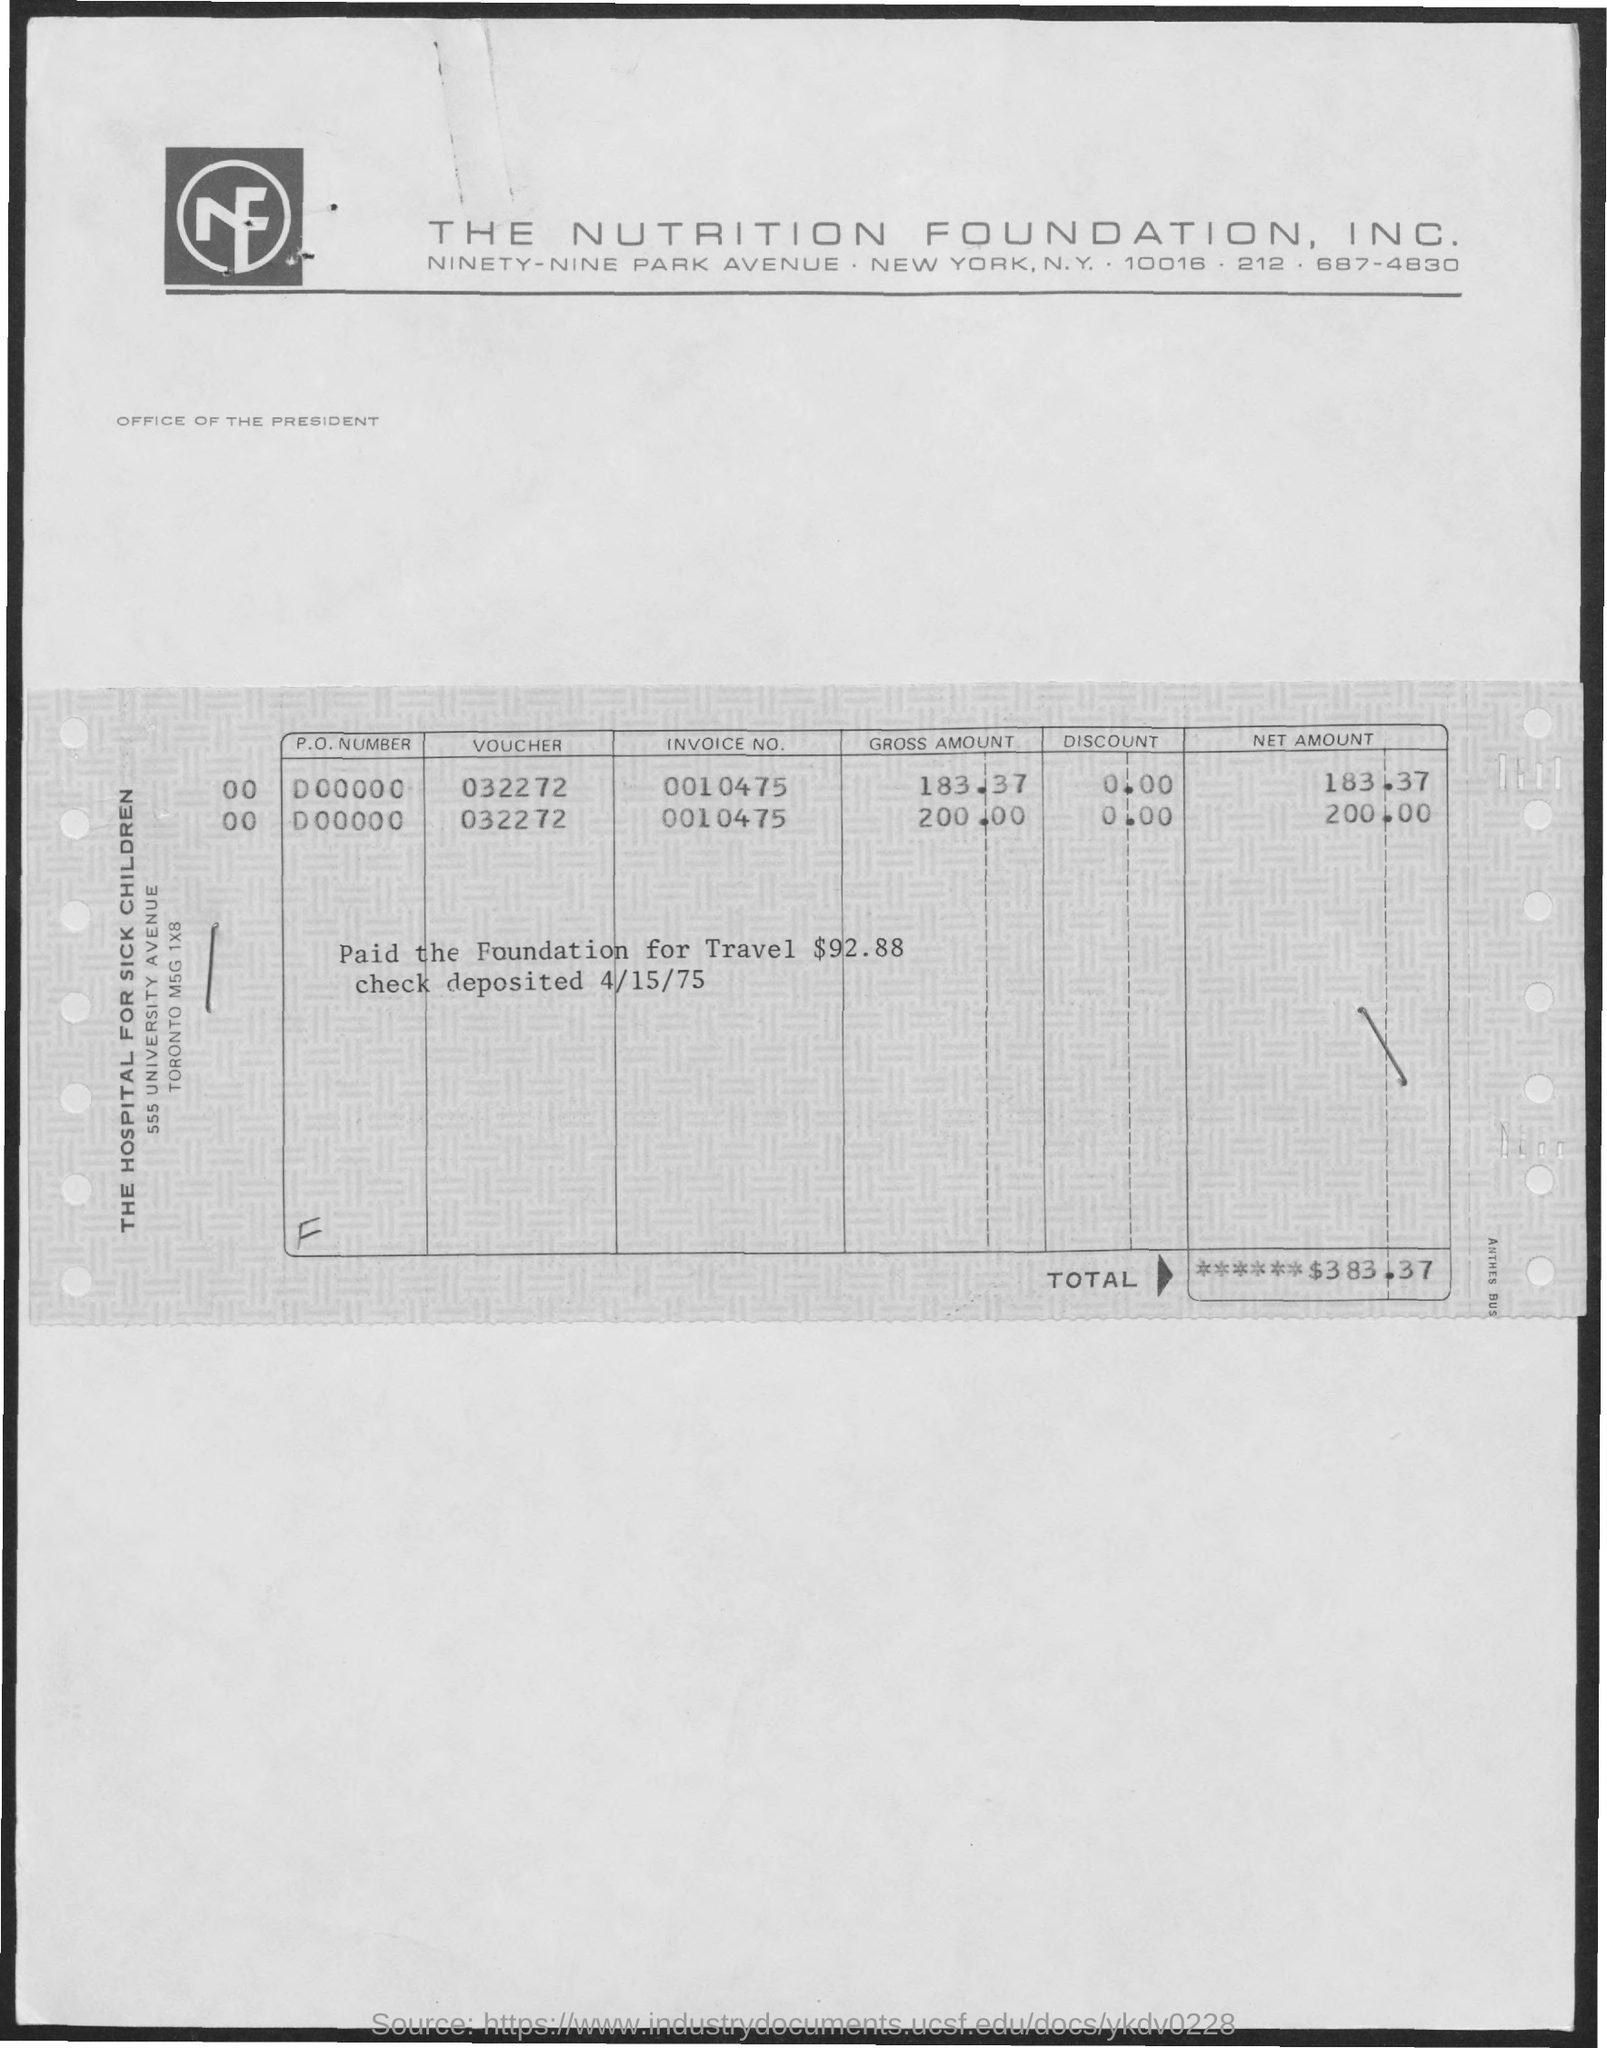What is the telephone number of nutrition foundation, inc?
Make the answer very short. 212. 687-4830. What is the total amount?
Your answer should be very brief. $ 383.37. What is the amount paid to the foundation for travel?
Offer a terse response. $92.88. 